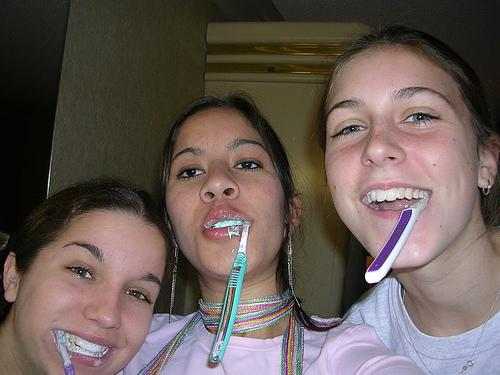What color is the toothbrush in the mouth of the woman in the center? green 